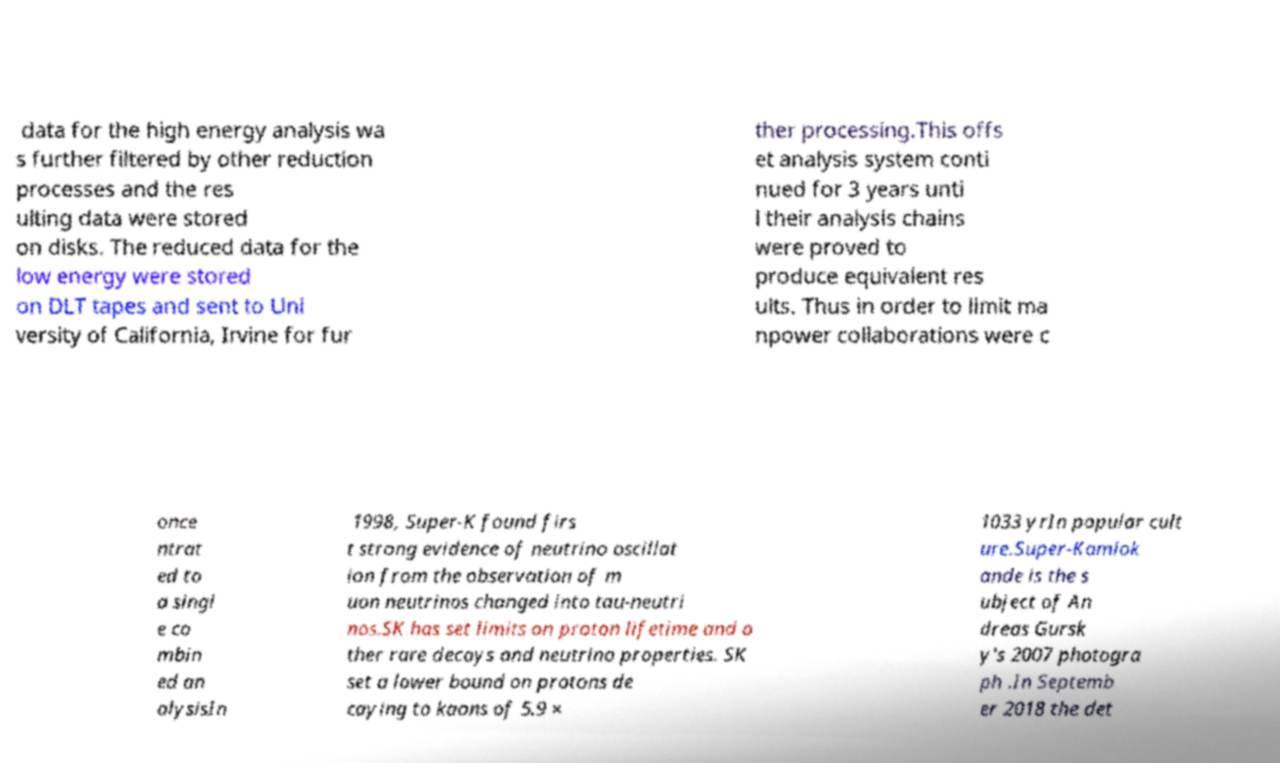Could you extract and type out the text from this image? data for the high energy analysis wa s further filtered by other reduction processes and the res ulting data were stored on disks. The reduced data for the low energy were stored on DLT tapes and sent to Uni versity of California, Irvine for fur ther processing.This offs et analysis system conti nued for 3 years unti l their analysis chains were proved to produce equivalent res ults. Thus in order to limit ma npower collaborations were c once ntrat ed to a singl e co mbin ed an alysisIn 1998, Super-K found firs t strong evidence of neutrino oscillat ion from the observation of m uon neutrinos changed into tau-neutri nos.SK has set limits on proton lifetime and o ther rare decays and neutrino properties. SK set a lower bound on protons de caying to kaons of 5.9 × 1033 yrIn popular cult ure.Super-Kamiok ande is the s ubject of An dreas Gursk y's 2007 photogra ph .In Septemb er 2018 the det 